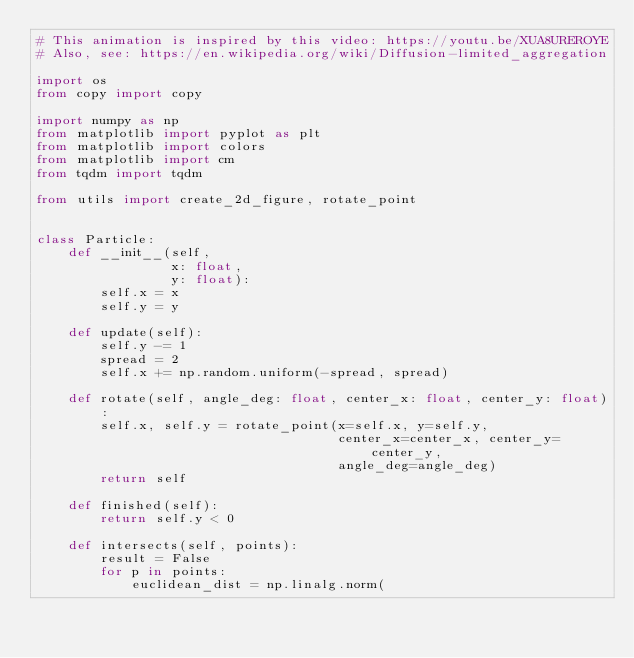<code> <loc_0><loc_0><loc_500><loc_500><_Python_># This animation is inspired by this video: https://youtu.be/XUA8UREROYE
# Also, see: https://en.wikipedia.org/wiki/Diffusion-limited_aggregation

import os
from copy import copy

import numpy as np
from matplotlib import pyplot as plt
from matplotlib import colors
from matplotlib import cm
from tqdm import tqdm

from utils import create_2d_figure, rotate_point


class Particle:
    def __init__(self,
                 x: float,
                 y: float):
        self.x = x
        self.y = y

    def update(self):
        self.y -= 1
        spread = 2
        self.x += np.random.uniform(-spread, spread)

    def rotate(self, angle_deg: float, center_x: float, center_y: float):
        self.x, self.y = rotate_point(x=self.x, y=self.y,
                                      center_x=center_x, center_y=center_y,
                                      angle_deg=angle_deg)
        return self

    def finished(self):
        return self.y < 0

    def intersects(self, points):
        result = False
        for p in points:
            euclidean_dist = np.linalg.norm(</code> 